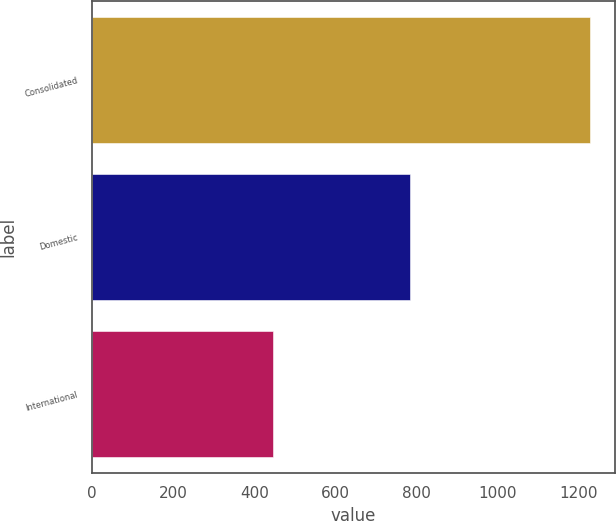<chart> <loc_0><loc_0><loc_500><loc_500><bar_chart><fcel>Consolidated<fcel>Domestic<fcel>International<nl><fcel>1227.7<fcel>782.8<fcel>444.9<nl></chart> 